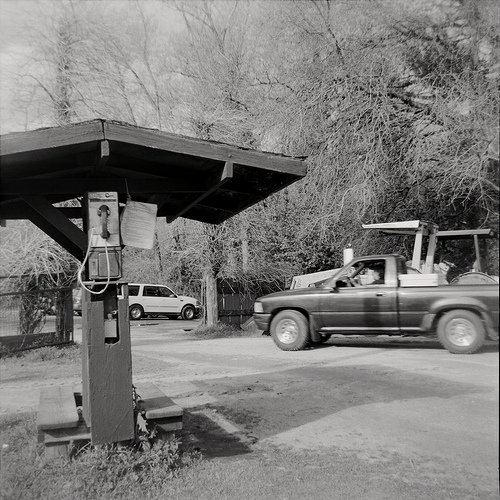Please provide the bounding box coordinate of the region this sentence describes: A dark metal fence. The bounding box for the dark metal fence is at coordinates [0.0, 0.54, 0.11, 0.69]. This area highlights the metal fence in the background of the scene. 